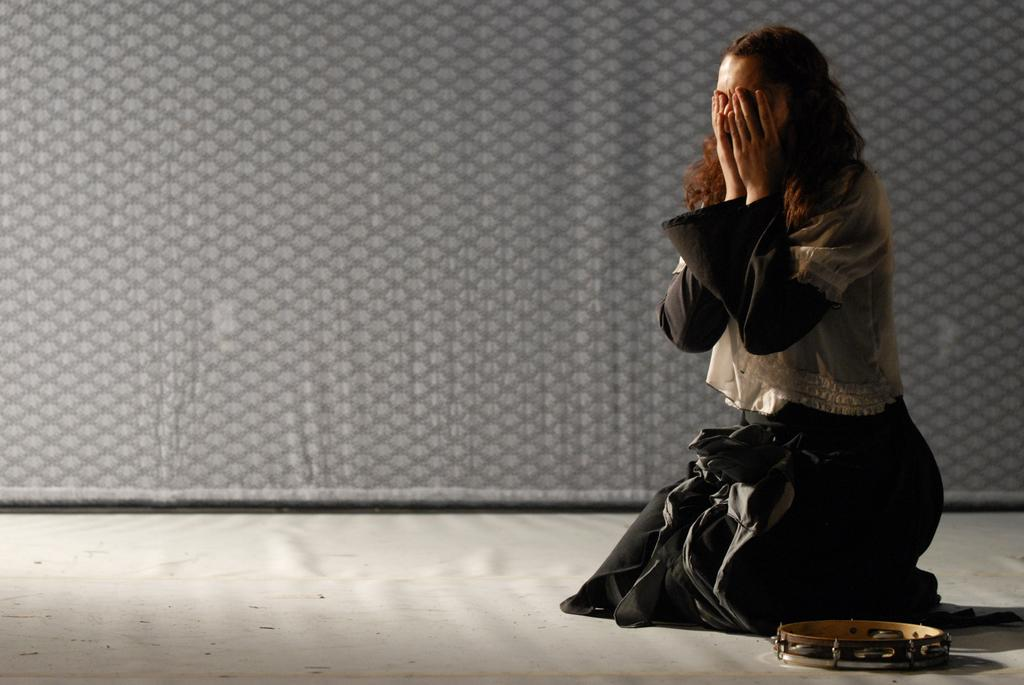What is the girl in the image doing? The girl is sitting on the ground in the image. How is the girl feeling in the image? The girl is crying in the image. What object is on the floor near the girl? There is a small drum on the floor in the image. What can be seen in the background of the image? There is a fabric design curtain in the background of the image. What type of veil is the girl wearing in the image? There is no veil present in the image; the girl is not wearing any head covering. 